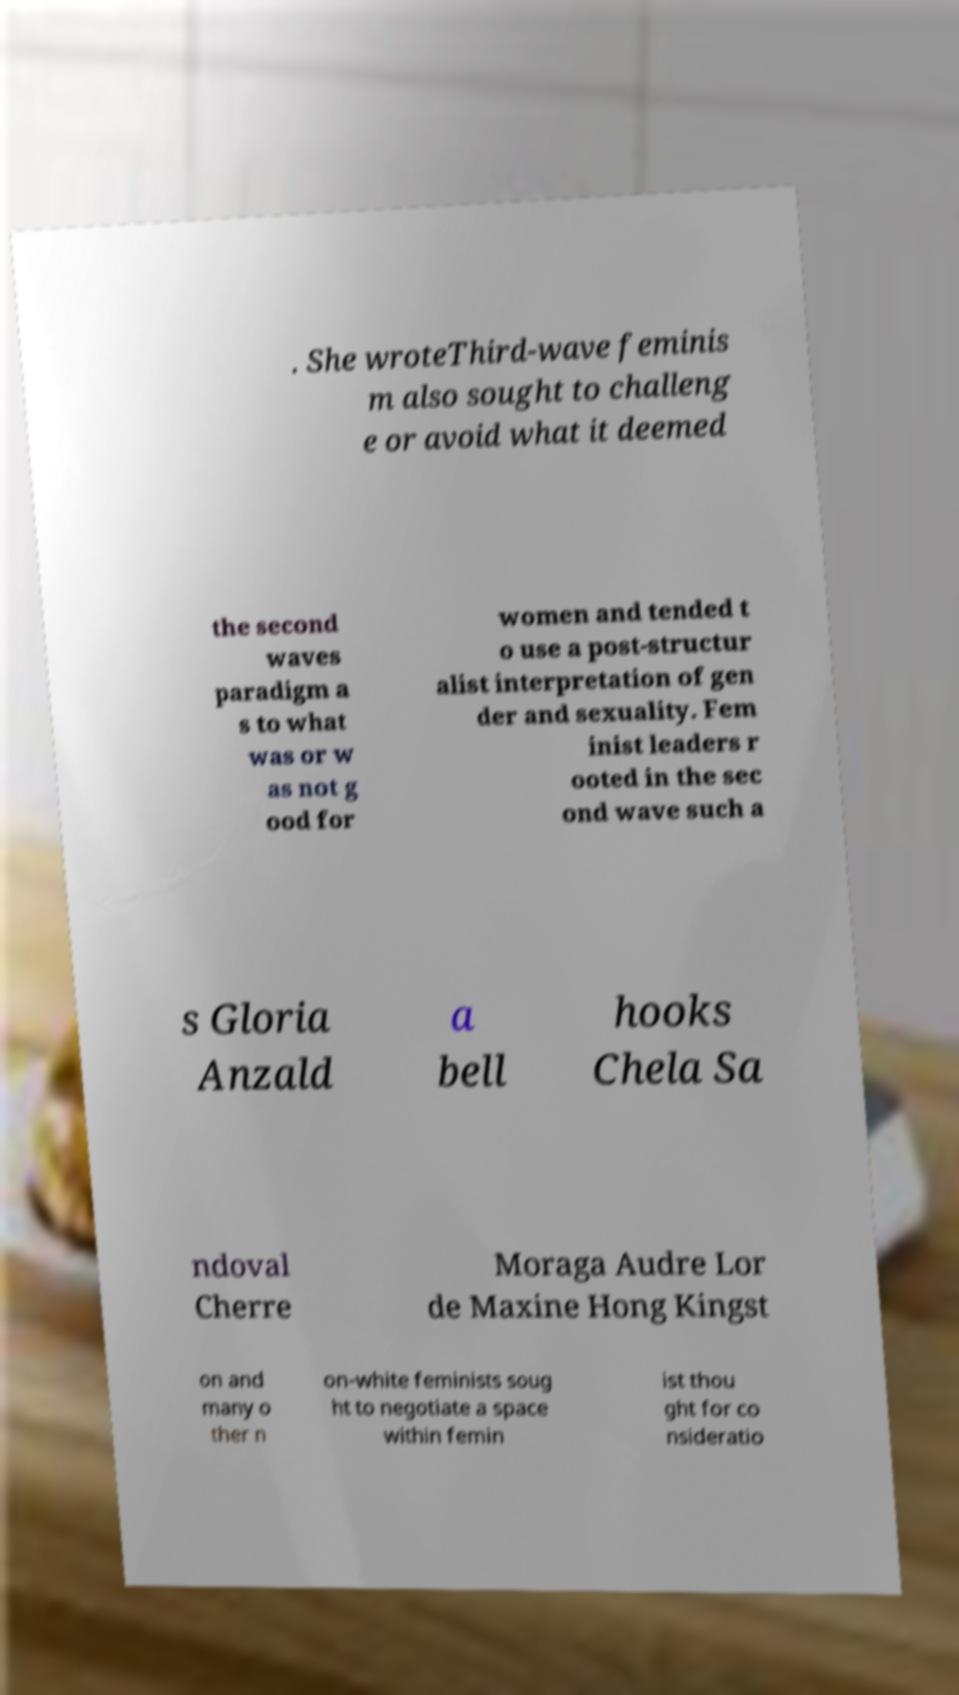Please read and relay the text visible in this image. What does it say? . She wroteThird-wave feminis m also sought to challeng e or avoid what it deemed the second waves paradigm a s to what was or w as not g ood for women and tended t o use a post-structur alist interpretation of gen der and sexuality. Fem inist leaders r ooted in the sec ond wave such a s Gloria Anzald a bell hooks Chela Sa ndoval Cherre Moraga Audre Lor de Maxine Hong Kingst on and many o ther n on-white feminists soug ht to negotiate a space within femin ist thou ght for co nsideratio 